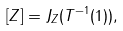Convert formula to latex. <formula><loc_0><loc_0><loc_500><loc_500>[ Z ] = J _ { Z } ( T ^ { - 1 } ( 1 ) ) ,</formula> 